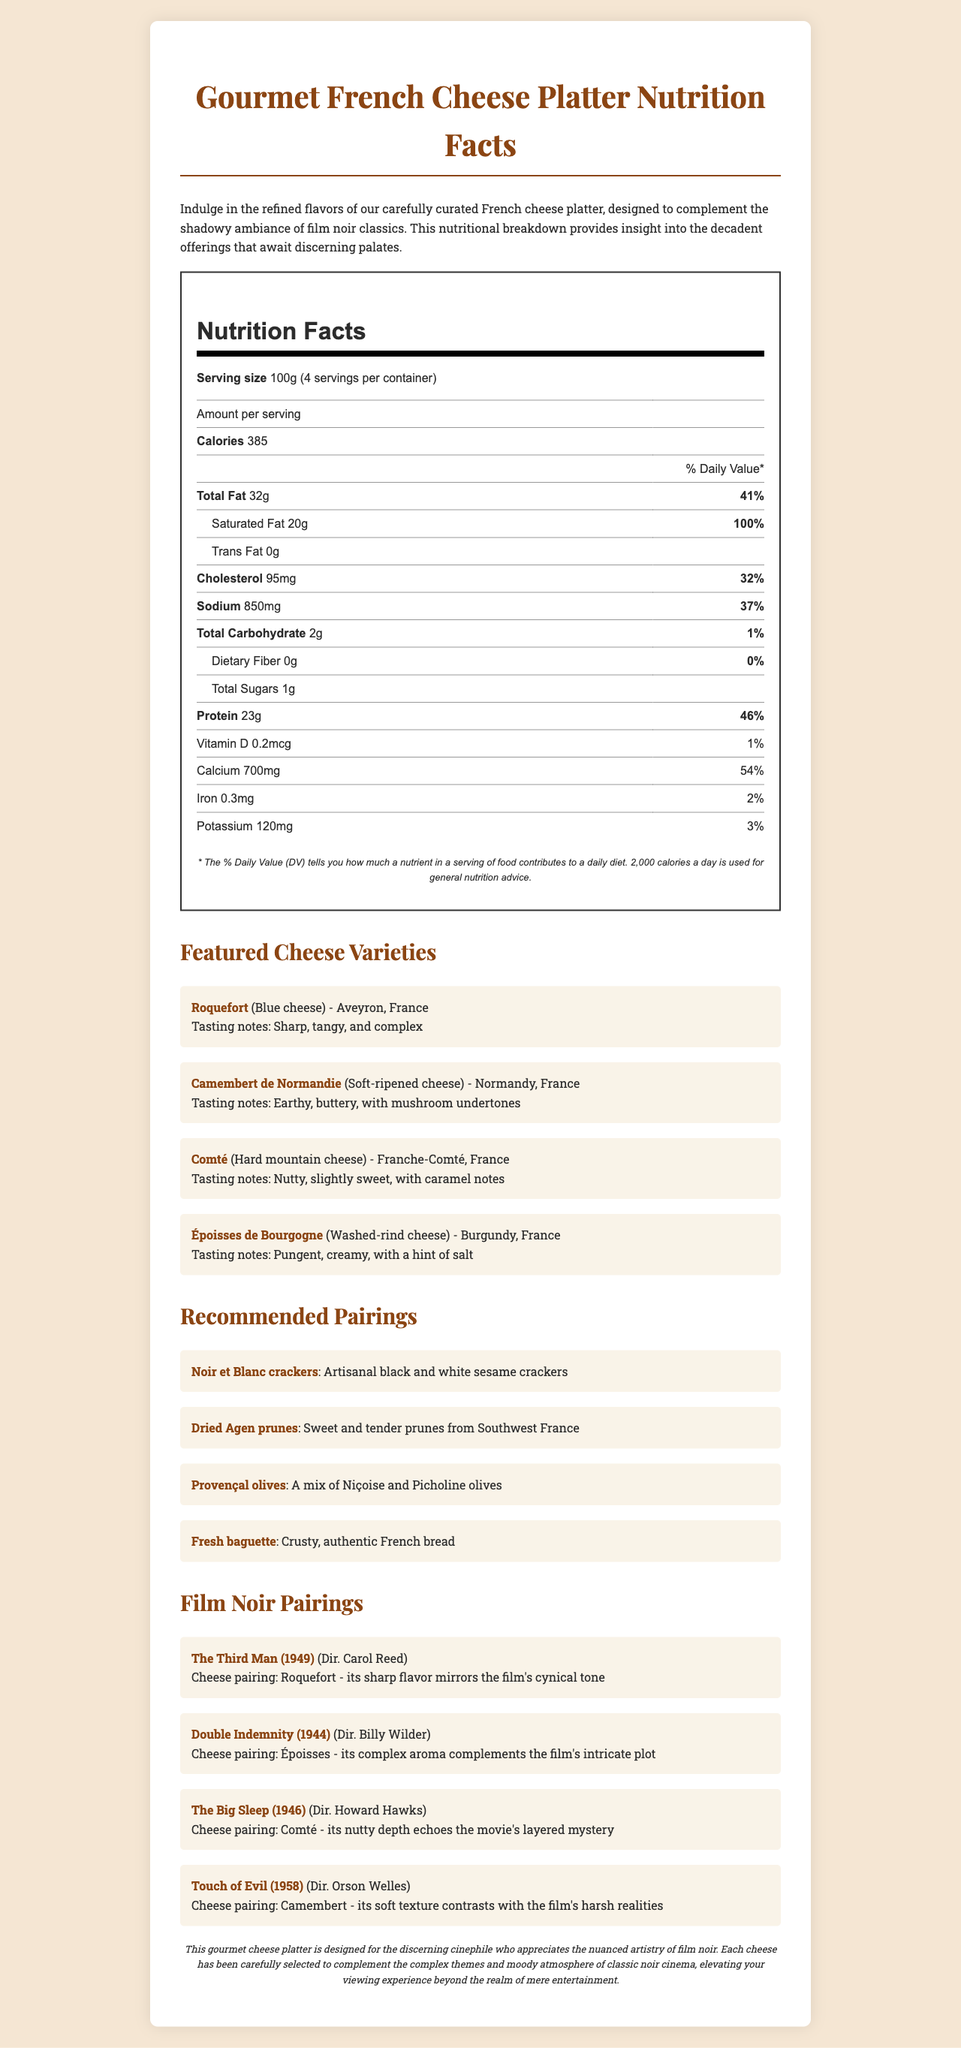what is the serving size for the cheese platter? The document states the serving size is 100g.
Answer: 100g how many servings are in the container? The document mentions there are 4 servings per container.
Answer: 4 how many calories are in one serving? The nutrition facts indicate that one serving contains 385 calories.
Answer: 385 what percentage of daily value is the total fat per serving? The document shows the total fat per serving is 32g, which is 41% of the daily value.
Answer: 41% which cheese has tasting notes that include mushroom undertones? The cheese varieties section notes that Camembert de Normandie has earthy, buttery flavors with mushroom undertones.
Answer: Camembert de Normandie which nutrient has the highest percentage of daily value in one serving? A. Saturated Fat B. Sodium C. Protein D. Calcium Saturated fat has a daily value of 100%, which is the highest compared to Sodium (37%), Protein (46%), and Calcium (54%).
Answer: A. Saturated Fat which of the following films is paired with a cheese that has nutty depth? 1. The Third Man 2. Double Indemnity 3. The Big Sleep 4. Touch of Evil The film list indicates that Comté, known for its nutty depth, is paired with The Big Sleep.
Answer: 3. The Big Sleep is there any trans fat in the cheese? The nutrition facts show that the amount of trans fat is 0g.
Answer: No summarize the document. The document aims to enhance the cinematic experience by pairing complex cheese flavors with the themes of classic film noir, alongside detailed nutritional information and pairing suggestions.
Answer: The document provides a detailed overview of the nutritional information and artisan cheese selections for a gourmet French cheese platter, curated to complement film noir movies. It includes serving size, calories, nutrient percentages, cheese varieties with tasting notes and regions, recommended pairings, and film noir pairings. what is the exact number of calories you would consume if you ate the entire container? The total is calculated by multiplying the calories per serving (385) by the number of servings (4).
Answer: 1540 calories where is Roquefort cheese sourced from? The cheese varieties section states that Roquefort comes from Aveyron, France.
Answer: Aveyron, France how much protein does one serving contain? The nutrition facts show there are 23g of protein per serving.
Answer: 23g what percentage of daily value does potassium provide in one serving? The nutrition facts indicate that potassium provides 3% of the daily value per serving.
Answer: 3% which item is recommended for pairing that has a mix of Niçoise and Picholine varieties? The recommended pairings section mentions Provençal olives as a mix of Niçoise and Picholine varieties.
Answer: Provençal olives which film's harsh realities are contrasted with the soft texture of Camembert? The film list notes that Camembert's soft texture contrasts with the harsh realities of the film "Touch of Evil".
Answer: Touch of Evil how many milligrams of calcium are in one serving? The nutrition facts indicate that one serving contains 700mg of calcium.
Answer: 700mg how many total sugars are in one serving of the cheese platter? The nutrition facts show that one serving contains 1g of total sugars.
Answer: 1g what is the daily value percentage for dietary fiber? The nutrition facts show that dietary fiber has a daily value of 0%.
Answer: 0% what is the sodium amount per serving in milligrams? A. 500mg B. 850mg C. 750mg D. 650mg The nutrition facts show that the sodium amount per serving is 850mg.
Answer: B. 850mg what is the total weight of saturated fat in four servings? To find this, multiply the saturated fat per serving (20g) by the number of servings (4), giving a total of 80g.
Answer: 80g which director is associated with the film 'Double Indemnity' paired with Époisses cheese? The film list pairs the film "Double Indemnity," directed by Billy Wilder, with Époisses cheese.
Answer: Billy Wilder are there any vitamins other than Vitamin D listed in the nutritional information? The nutritional information only lists Vitamin D among the vitamins.
Answer: No 